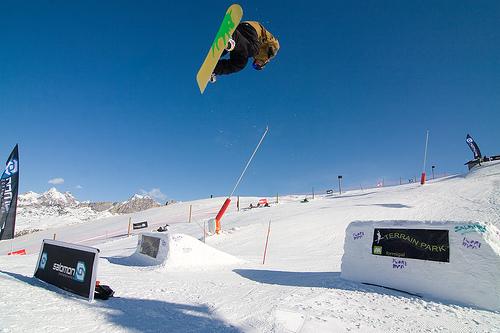What are these people up in the air on?
Be succinct. Snowboard. What is the person doing?
Short answer required. Snowboarding. Is this dangerous?
Short answer required. Yes. Does this scene feature snow or a beach?
Concise answer only. Snow. On the horizon, what are the white puffy things?
Write a very short answer. Clouds. 